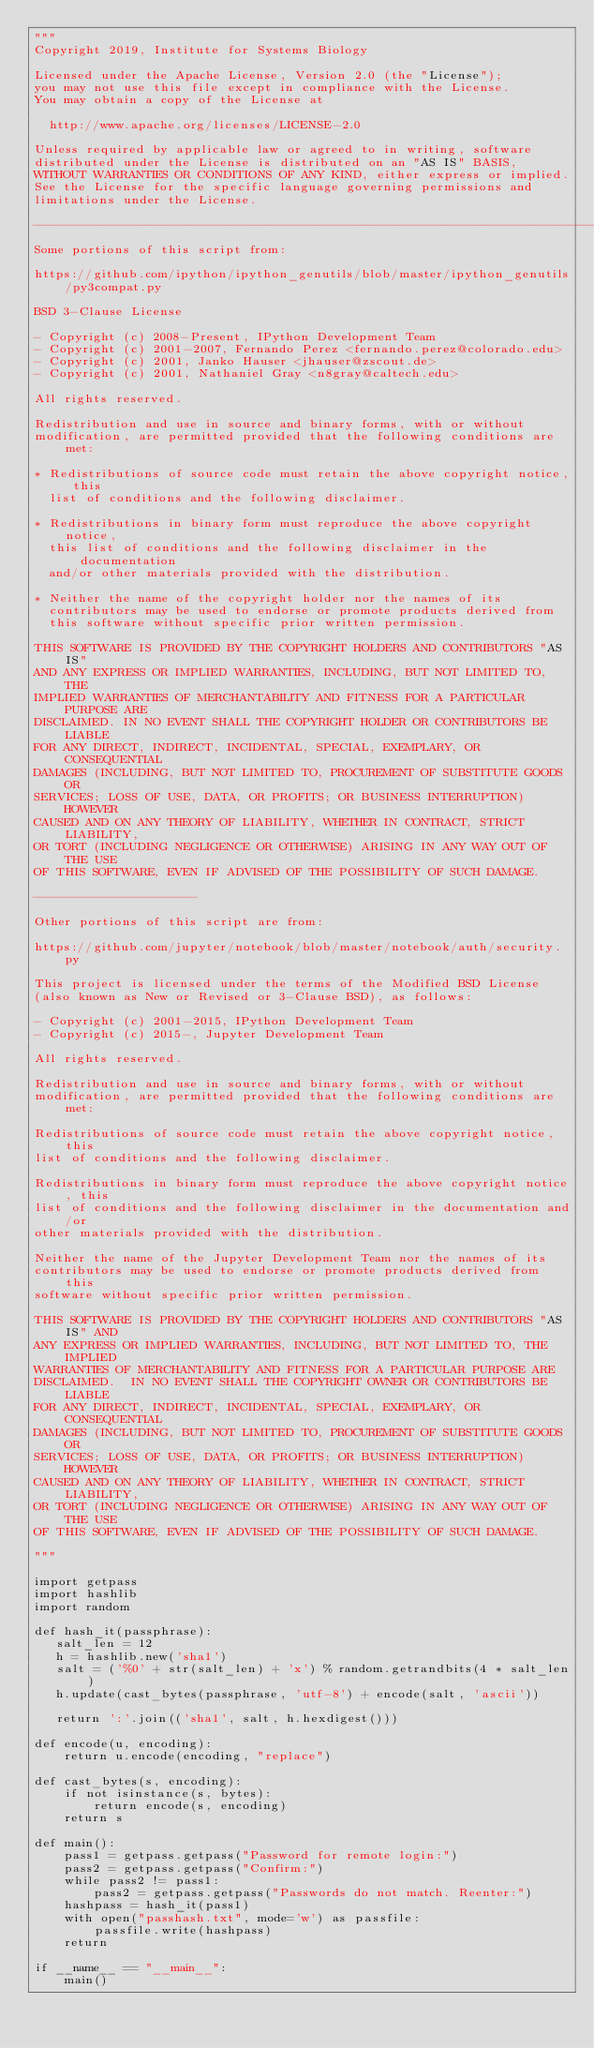Convert code to text. <code><loc_0><loc_0><loc_500><loc_500><_Python_>"""
Copyright 2019, Institute for Systems Biology

Licensed under the Apache License, Version 2.0 (the "License");
you may not use this file except in compliance with the License.
You may obtain a copy of the License at

  http://www.apache.org/licenses/LICENSE-2.0

Unless required by applicable law or agreed to in writing, software
distributed under the License is distributed on an "AS IS" BASIS,
WITHOUT WARRANTIES OR CONDITIONS OF ANY KIND, either express or implied.
See the License for the specific language governing permissions and
limitations under the License.

--------------------------------------------------------------------------------
Some portions of this script from:

https://github.com/ipython/ipython_genutils/blob/master/ipython_genutils/py3compat.py

BSD 3-Clause License

- Copyright (c) 2008-Present, IPython Development Team
- Copyright (c) 2001-2007, Fernando Perez <fernando.perez@colorado.edu>
- Copyright (c) 2001, Janko Hauser <jhauser@zscout.de>
- Copyright (c) 2001, Nathaniel Gray <n8gray@caltech.edu>

All rights reserved.

Redistribution and use in source and binary forms, with or without
modification, are permitted provided that the following conditions are met:

* Redistributions of source code must retain the above copyright notice, this
  list of conditions and the following disclaimer.

* Redistributions in binary form must reproduce the above copyright notice,
  this list of conditions and the following disclaimer in the documentation
  and/or other materials provided with the distribution.

* Neither the name of the copyright holder nor the names of its
  contributors may be used to endorse or promote products derived from
  this software without specific prior written permission.

THIS SOFTWARE IS PROVIDED BY THE COPYRIGHT HOLDERS AND CONTRIBUTORS "AS IS"
AND ANY EXPRESS OR IMPLIED WARRANTIES, INCLUDING, BUT NOT LIMITED TO, THE
IMPLIED WARRANTIES OF MERCHANTABILITY AND FITNESS FOR A PARTICULAR PURPOSE ARE
DISCLAIMED. IN NO EVENT SHALL THE COPYRIGHT HOLDER OR CONTRIBUTORS BE LIABLE
FOR ANY DIRECT, INDIRECT, INCIDENTAL, SPECIAL, EXEMPLARY, OR CONSEQUENTIAL
DAMAGES (INCLUDING, BUT NOT LIMITED TO, PROCUREMENT OF SUBSTITUTE GOODS OR
SERVICES; LOSS OF USE, DATA, OR PROFITS; OR BUSINESS INTERRUPTION) HOWEVER
CAUSED AND ON ANY THEORY OF LIABILITY, WHETHER IN CONTRACT, STRICT LIABILITY,
OR TORT (INCLUDING NEGLIGENCE OR OTHERWISE) ARISING IN ANY WAY OUT OF THE USE
OF THIS SOFTWARE, EVEN IF ADVISED OF THE POSSIBILITY OF SUCH DAMAGE.

----------------------

Other portions of this script are from:

https://github.com/jupyter/notebook/blob/master/notebook/auth/security.py

This project is licensed under the terms of the Modified BSD License
(also known as New or Revised or 3-Clause BSD), as follows:

- Copyright (c) 2001-2015, IPython Development Team
- Copyright (c) 2015-, Jupyter Development Team

All rights reserved.

Redistribution and use in source and binary forms, with or without
modification, are permitted provided that the following conditions are met:

Redistributions of source code must retain the above copyright notice, this
list of conditions and the following disclaimer.

Redistributions in binary form must reproduce the above copyright notice, this
list of conditions and the following disclaimer in the documentation and/or
other materials provided with the distribution.

Neither the name of the Jupyter Development Team nor the names of its
contributors may be used to endorse or promote products derived from this
software without specific prior written permission.

THIS SOFTWARE IS PROVIDED BY THE COPYRIGHT HOLDERS AND CONTRIBUTORS "AS IS" AND
ANY EXPRESS OR IMPLIED WARRANTIES, INCLUDING, BUT NOT LIMITED TO, THE IMPLIED
WARRANTIES OF MERCHANTABILITY AND FITNESS FOR A PARTICULAR PURPOSE ARE
DISCLAIMED.  IN NO EVENT SHALL THE COPYRIGHT OWNER OR CONTRIBUTORS BE LIABLE
FOR ANY DIRECT, INDIRECT, INCIDENTAL, SPECIAL, EXEMPLARY, OR CONSEQUENTIAL
DAMAGES (INCLUDING, BUT NOT LIMITED TO, PROCUREMENT OF SUBSTITUTE GOODS OR
SERVICES; LOSS OF USE, DATA, OR PROFITS; OR BUSINESS INTERRUPTION) HOWEVER
CAUSED AND ON ANY THEORY OF LIABILITY, WHETHER IN CONTRACT, STRICT LIABILITY,
OR TORT (INCLUDING NEGLIGENCE OR OTHERWISE) ARISING IN ANY WAY OUT OF THE USE
OF THIS SOFTWARE, EVEN IF ADVISED OF THE POSSIBILITY OF SUCH DAMAGE.

"""

import getpass
import hashlib
import random

def hash_it(passphrase):
   salt_len = 12
   h = hashlib.new('sha1')
   salt = ('%0' + str(salt_len) + 'x') % random.getrandbits(4 * salt_len)
   h.update(cast_bytes(passphrase, 'utf-8') + encode(salt, 'ascii'))

   return ':'.join(('sha1', salt, h.hexdigest()))

def encode(u, encoding):
    return u.encode(encoding, "replace")

def cast_bytes(s, encoding):
    if not isinstance(s, bytes):
        return encode(s, encoding)
    return s

def main():
    pass1 = getpass.getpass("Password for remote login:")
    pass2 = getpass.getpass("Confirm:")
    while pass2 != pass1:
        pass2 = getpass.getpass("Passwords do not match. Reenter:")
    hashpass = hash_it(pass1)
    with open("passhash.txt", mode='w') as passfile:
        passfile.write(hashpass)
    return

if __name__ == "__main__":
    main()</code> 